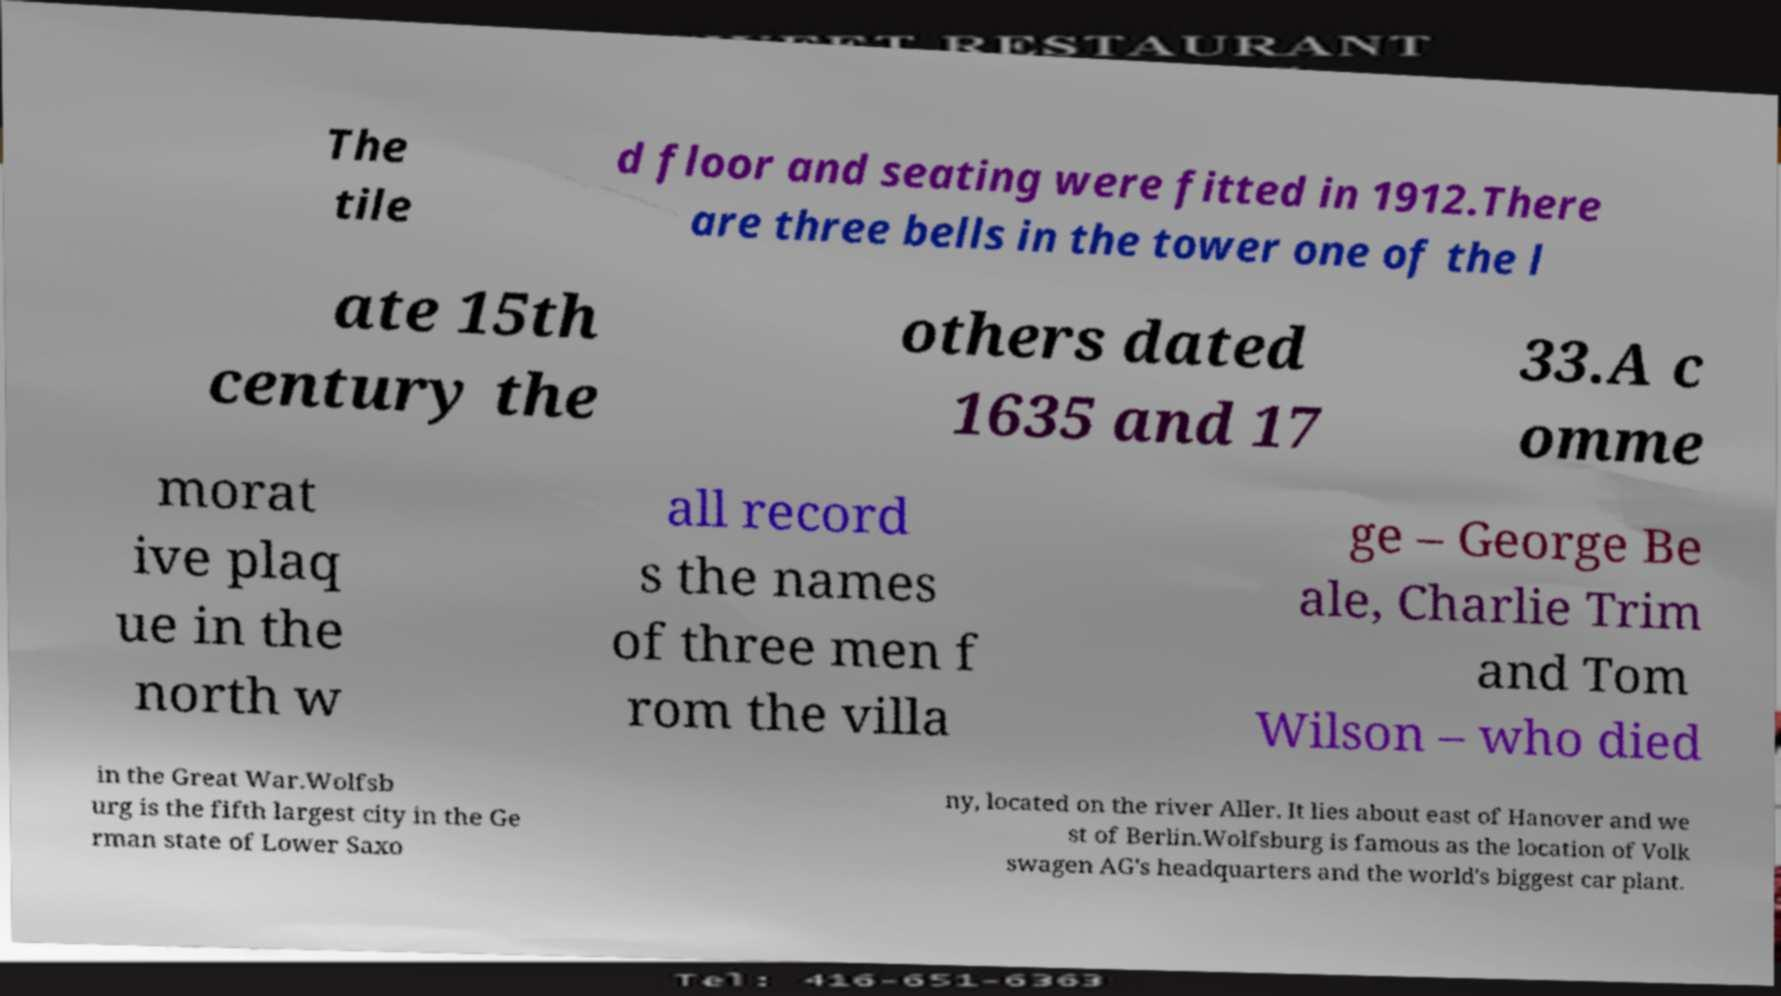For documentation purposes, I need the text within this image transcribed. Could you provide that? The tile d floor and seating were fitted in 1912.There are three bells in the tower one of the l ate 15th century the others dated 1635 and 17 33.A c omme morat ive plaq ue in the north w all record s the names of three men f rom the villa ge – George Be ale, Charlie Trim and Tom Wilson – who died in the Great War.Wolfsb urg is the fifth largest city in the Ge rman state of Lower Saxo ny, located on the river Aller. It lies about east of Hanover and we st of Berlin.Wolfsburg is famous as the location of Volk swagen AG's headquarters and the world's biggest car plant. 